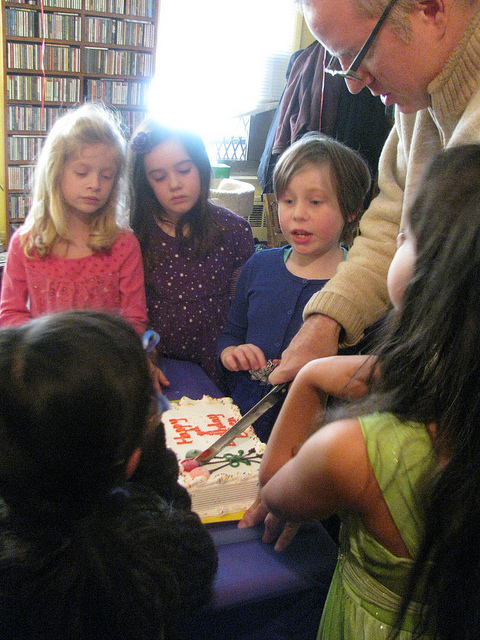Read all the text in this image. Happy Birthday 